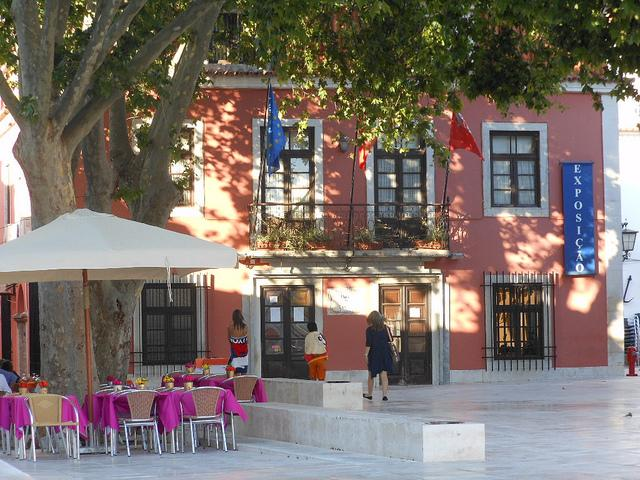What event is being held here? Please explain your reasoning. expo. An expo is the event going on. 